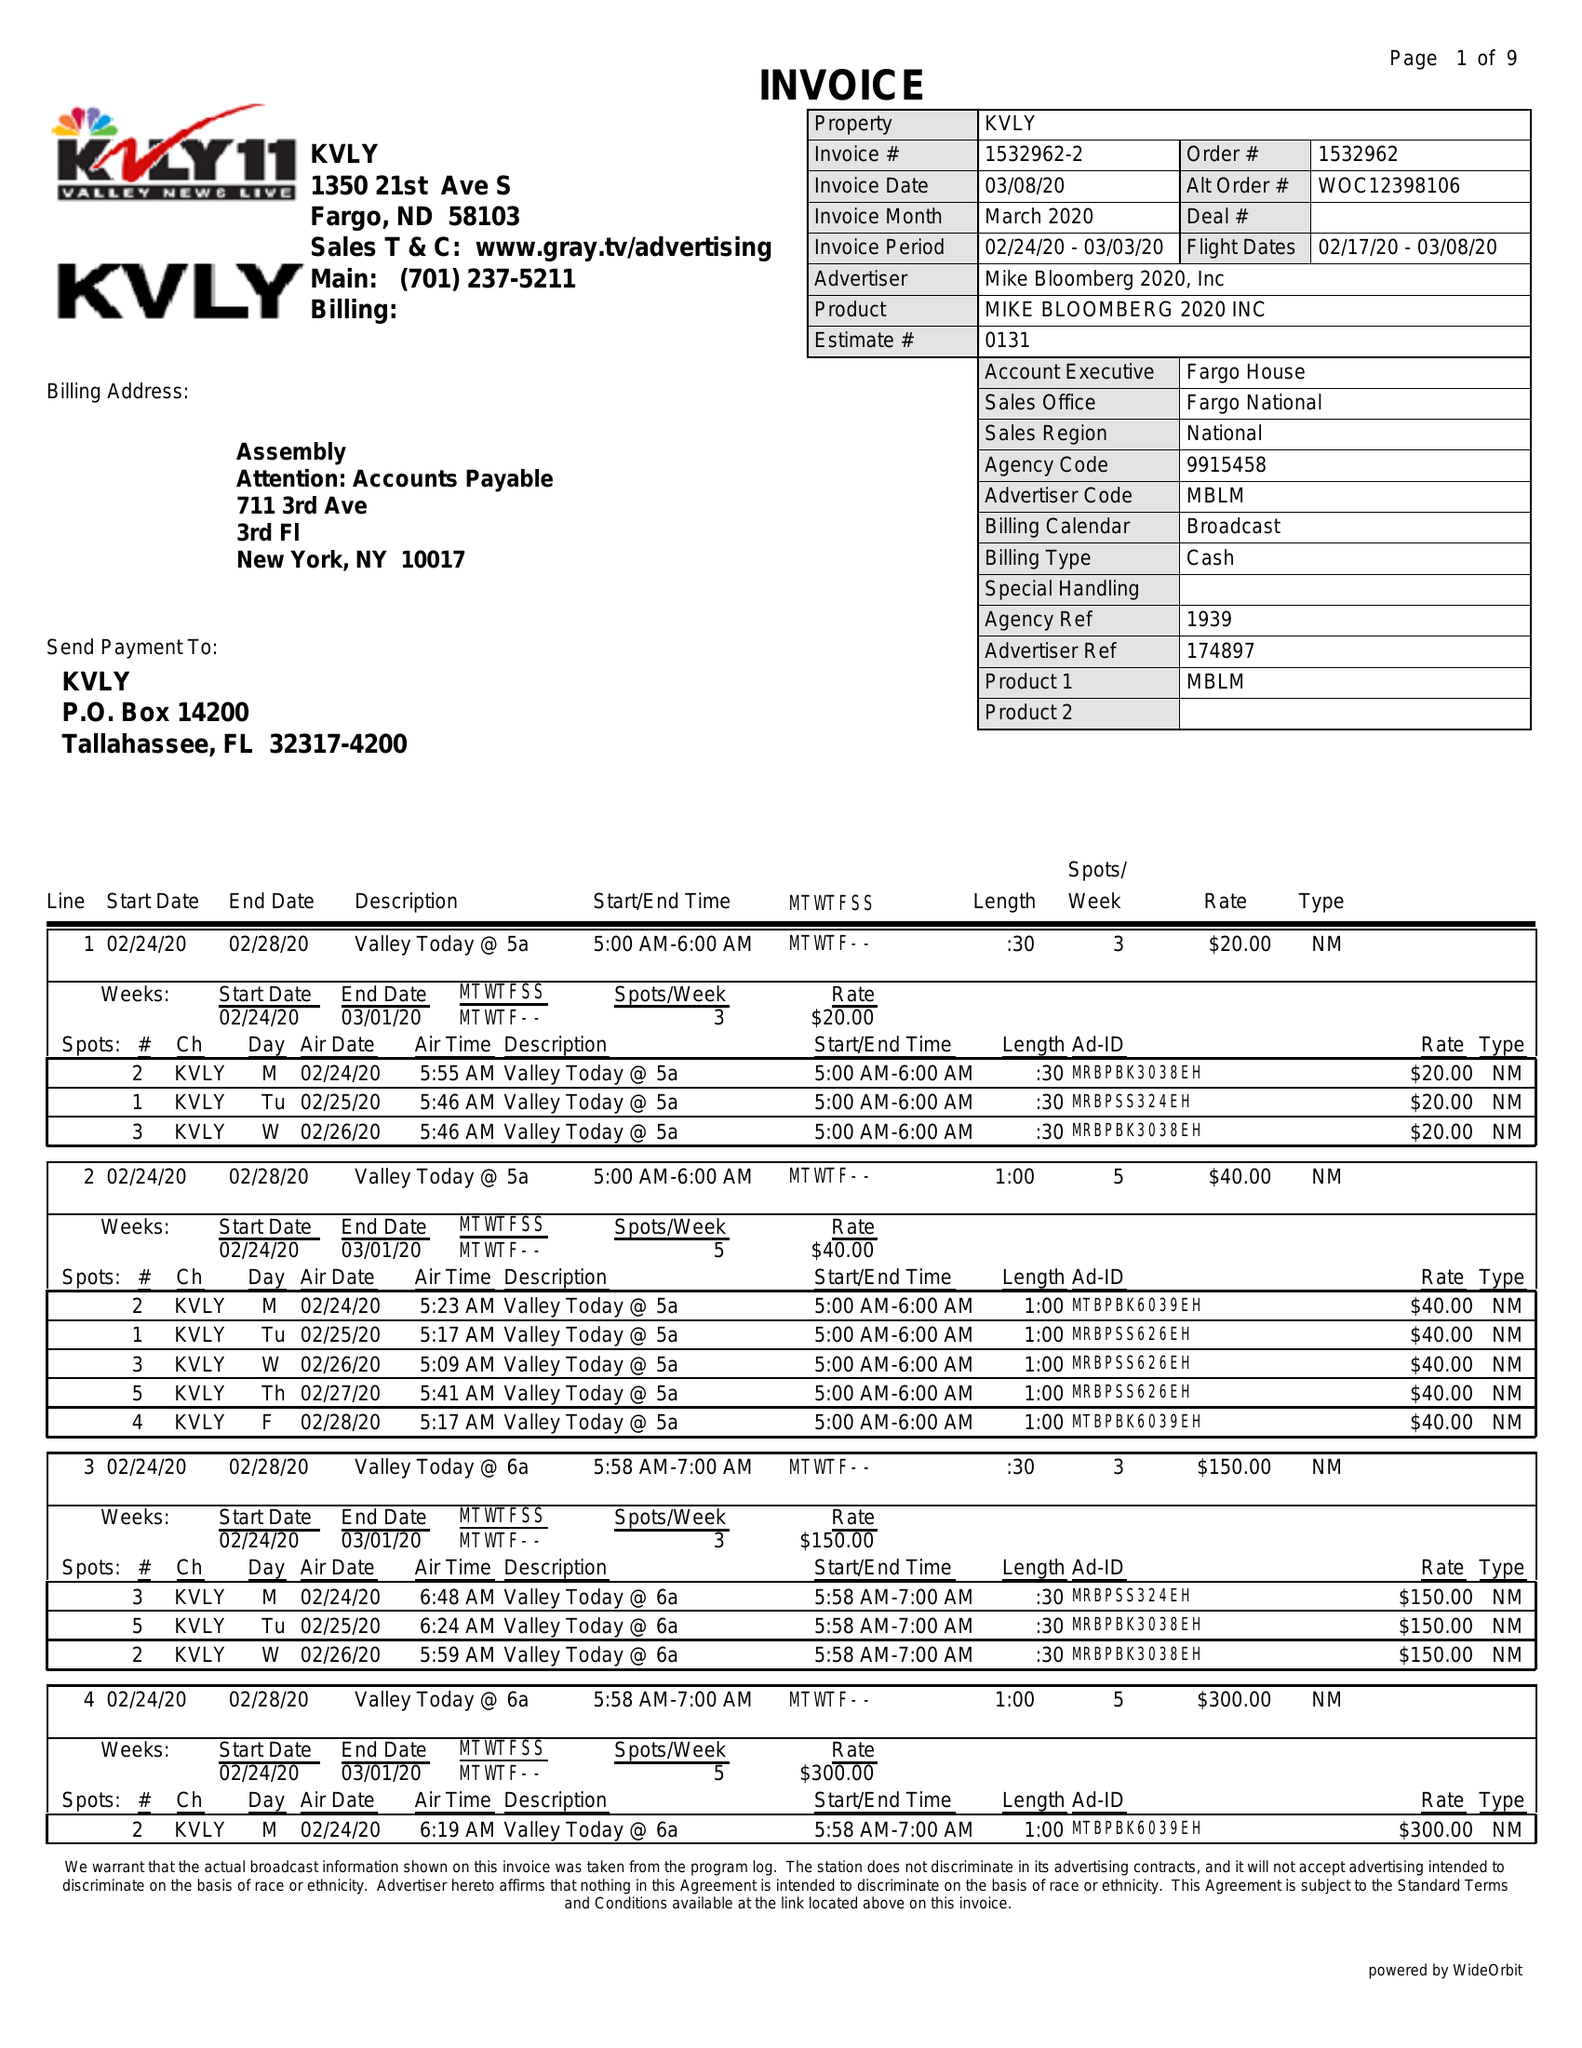What is the value for the flight_from?
Answer the question using a single word or phrase. 02/17/20 